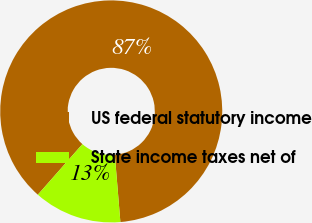Convert chart. <chart><loc_0><loc_0><loc_500><loc_500><pie_chart><fcel>US federal statutory income<fcel>State income taxes net of<nl><fcel>87.19%<fcel>12.81%<nl></chart> 